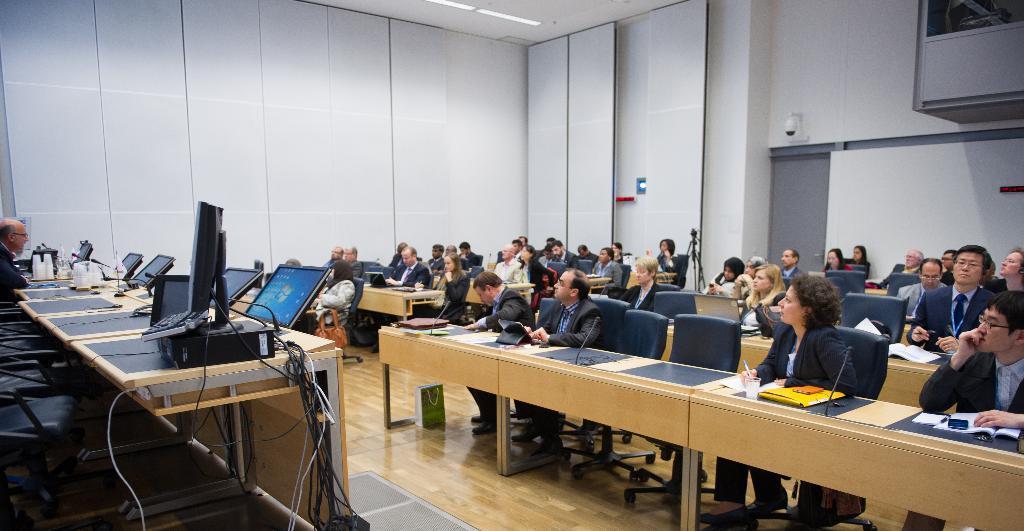In one or two sentences, can you explain what this image depicts? There are few people here sitting on the chair at their tables. On the table there are books,microphone,glasses. On the right a person is sitting on the chair and looking at them. In this room there are laptops,cables,cc camera. 